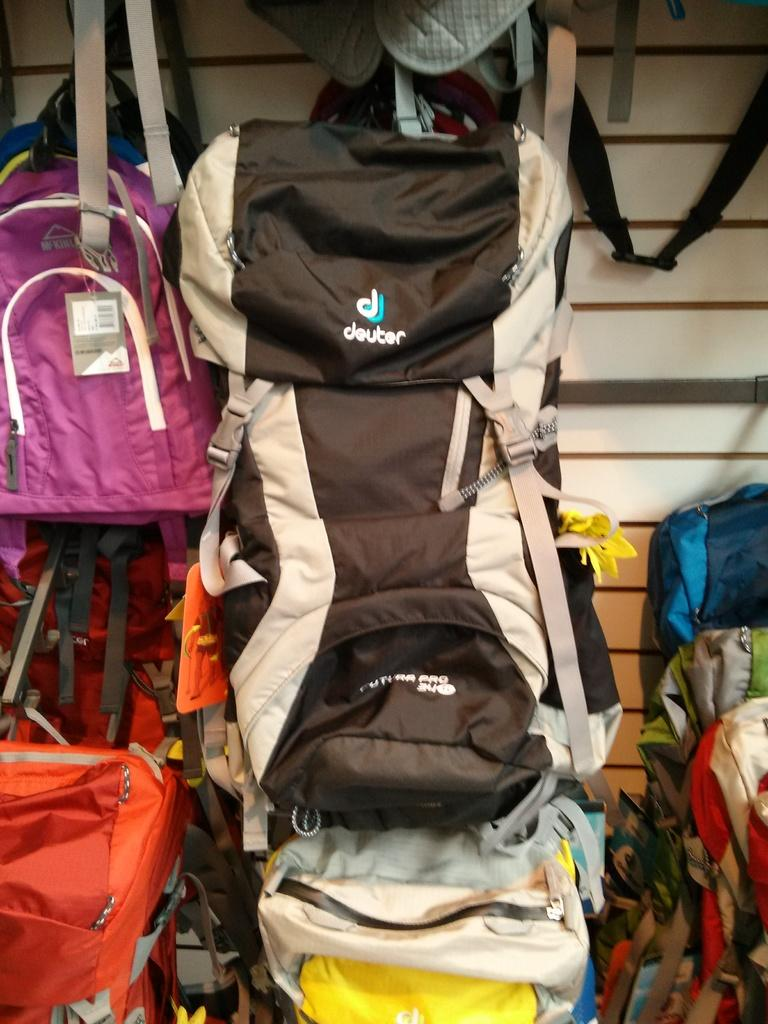Provide a one-sentence caption for the provided image. a Deuter backpack is hung up on display with others. 